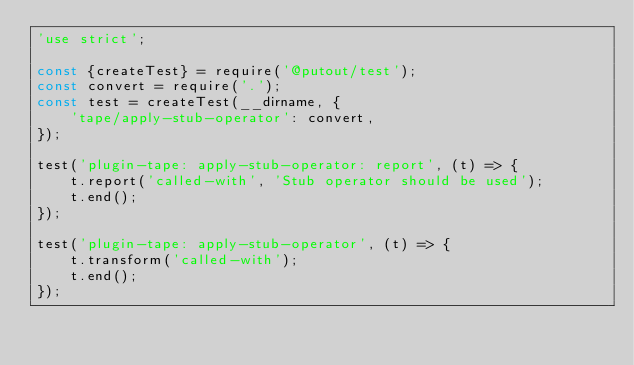Convert code to text. <code><loc_0><loc_0><loc_500><loc_500><_JavaScript_>'use strict';

const {createTest} = require('@putout/test');
const convert = require('.');
const test = createTest(__dirname, {
    'tape/apply-stub-operator': convert,
});

test('plugin-tape: apply-stub-operator: report', (t) => {
    t.report('called-with', 'Stub operator should be used');
    t.end();
});

test('plugin-tape: apply-stub-operator', (t) => {
    t.transform('called-with');
    t.end();
});

</code> 